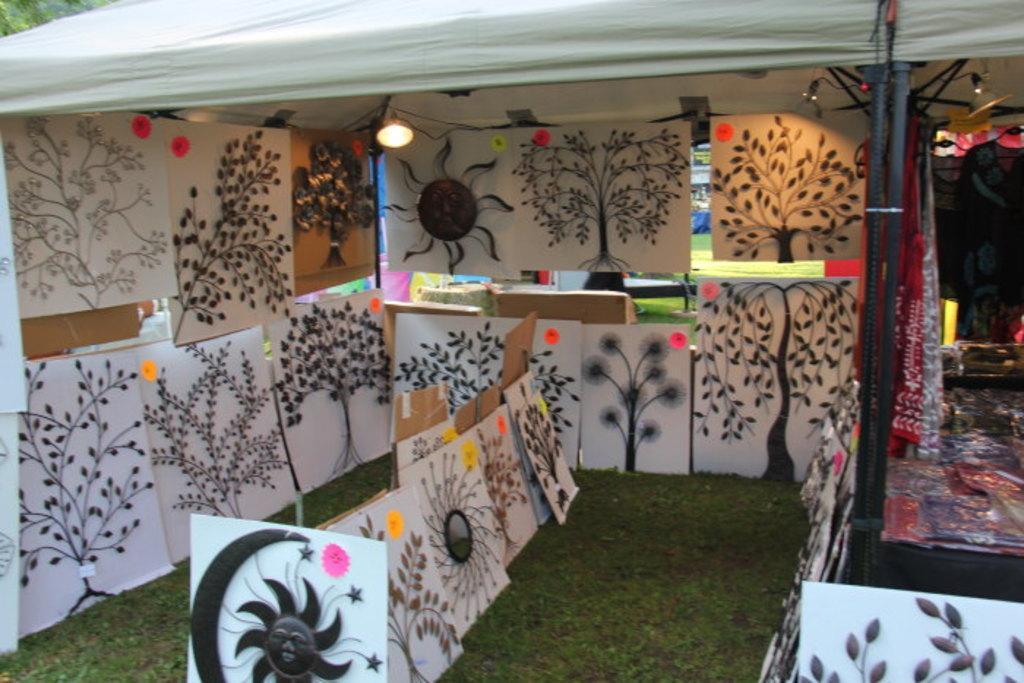Could you give a brief overview of what you see in this image? In this picture we can see there are drawing papers in the stall and on the table there are some plastic covers and at the top there are lights. 